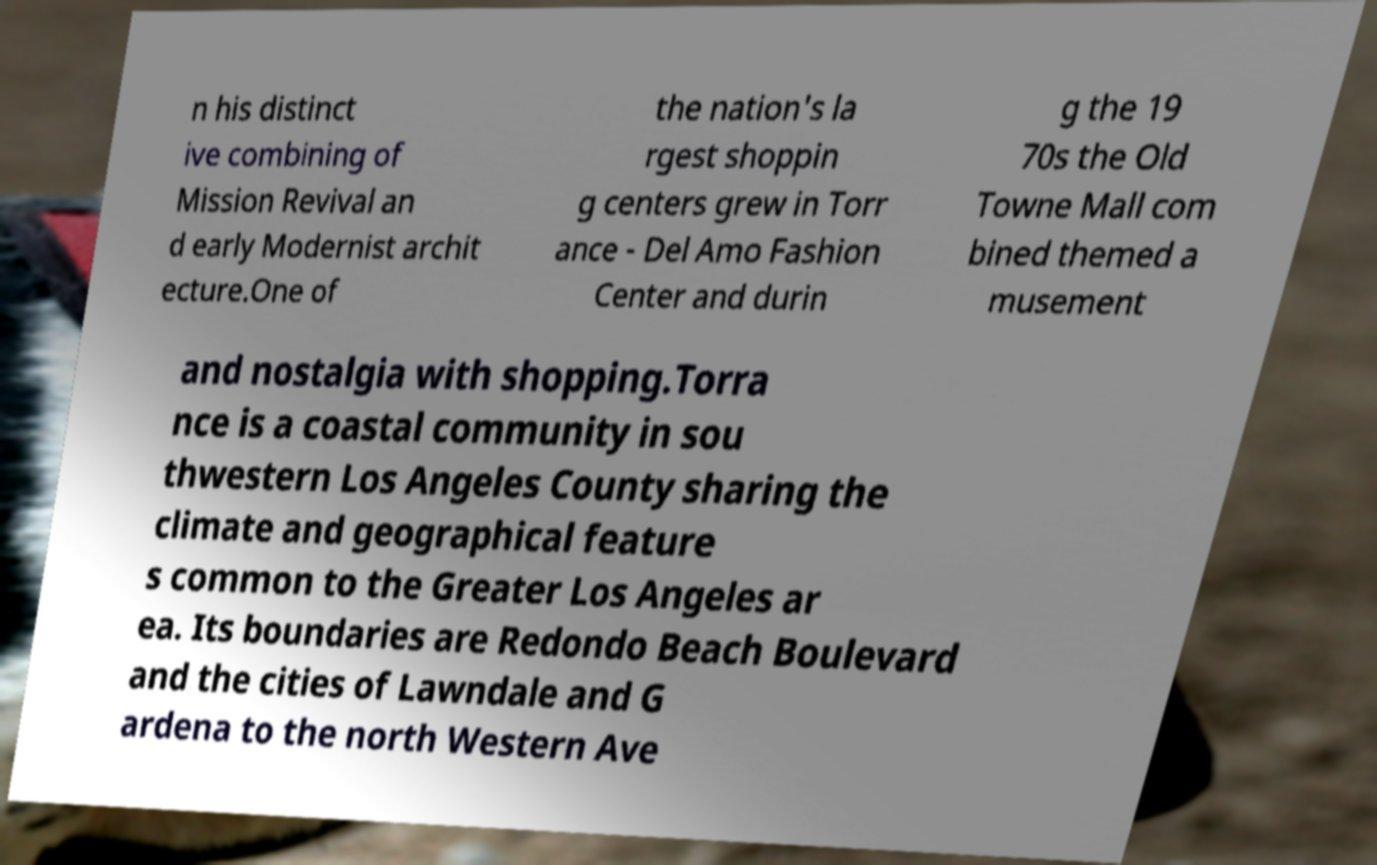For documentation purposes, I need the text within this image transcribed. Could you provide that? n his distinct ive combining of Mission Revival an d early Modernist archit ecture.One of the nation's la rgest shoppin g centers grew in Torr ance - Del Amo Fashion Center and durin g the 19 70s the Old Towne Mall com bined themed a musement and nostalgia with shopping.Torra nce is a coastal community in sou thwestern Los Angeles County sharing the climate and geographical feature s common to the Greater Los Angeles ar ea. Its boundaries are Redondo Beach Boulevard and the cities of Lawndale and G ardena to the north Western Ave 